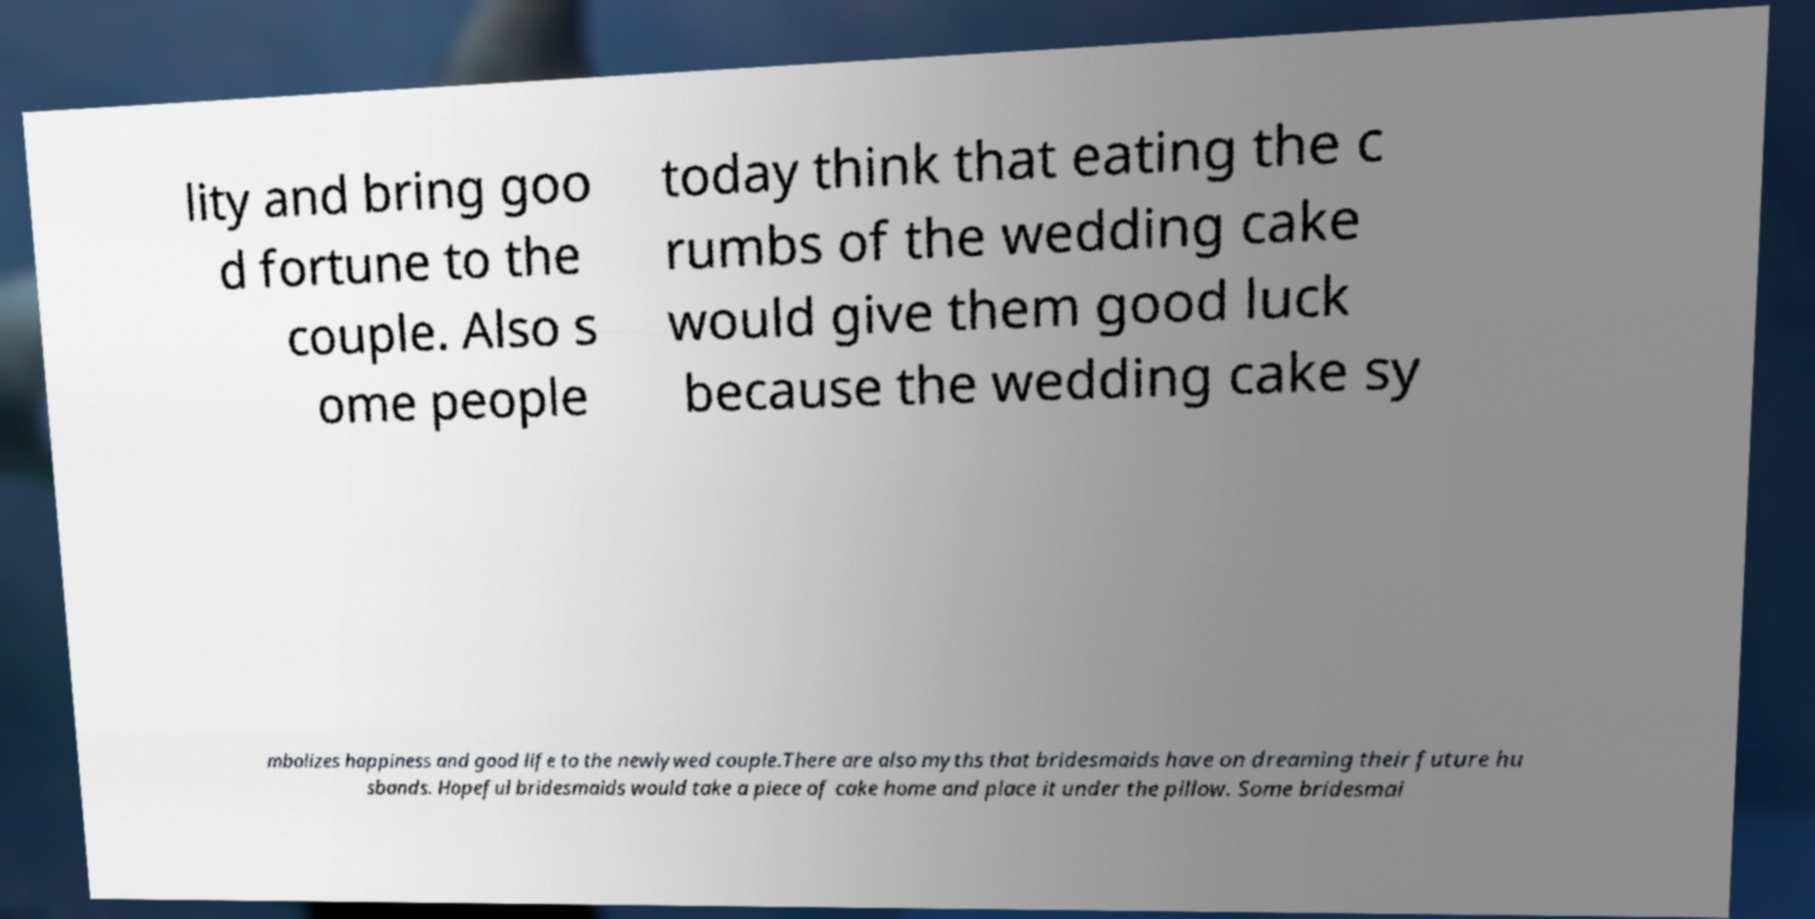For documentation purposes, I need the text within this image transcribed. Could you provide that? lity and bring goo d fortune to the couple. Also s ome people today think that eating the c rumbs of the wedding cake would give them good luck because the wedding cake sy mbolizes happiness and good life to the newlywed couple.There are also myths that bridesmaids have on dreaming their future hu sbands. Hopeful bridesmaids would take a piece of cake home and place it under the pillow. Some bridesmai 